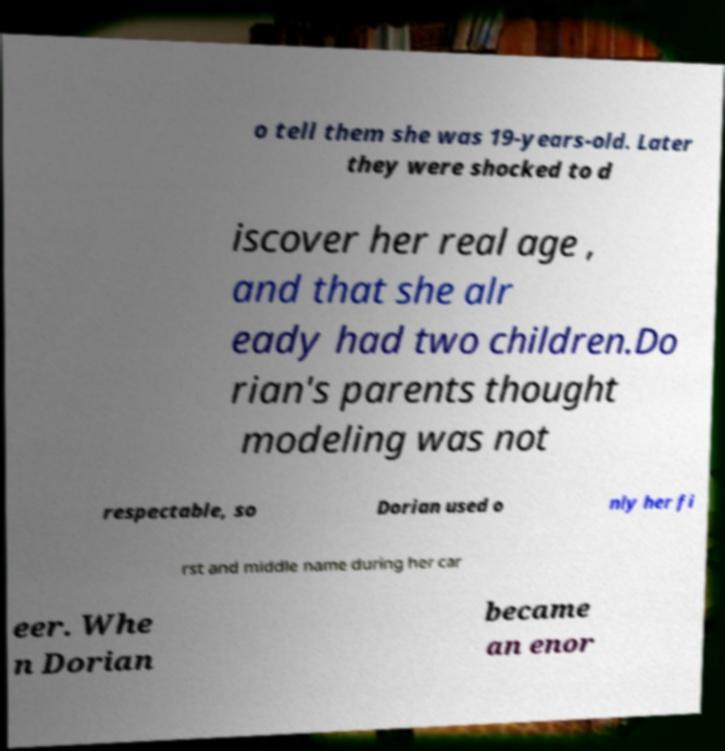There's text embedded in this image that I need extracted. Can you transcribe it verbatim? o tell them she was 19-years-old. Later they were shocked to d iscover her real age , and that she alr eady had two children.Do rian's parents thought modeling was not respectable, so Dorian used o nly her fi rst and middle name during her car eer. Whe n Dorian became an enor 